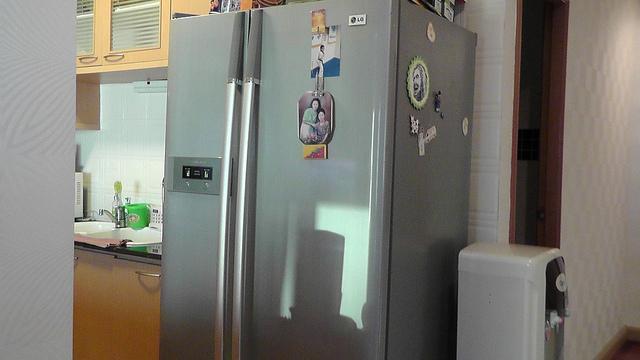How many pink umbrellas are in this image?
Give a very brief answer. 0. 